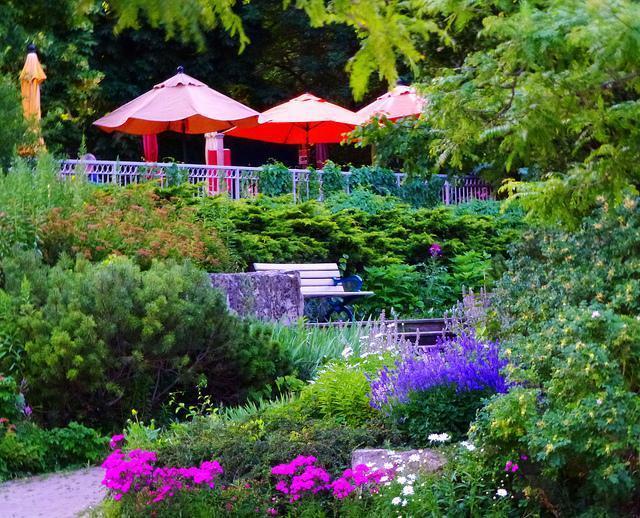How many umbrellas are visible?
Give a very brief answer. 3. How many dogs is the man walking?
Give a very brief answer. 0. 